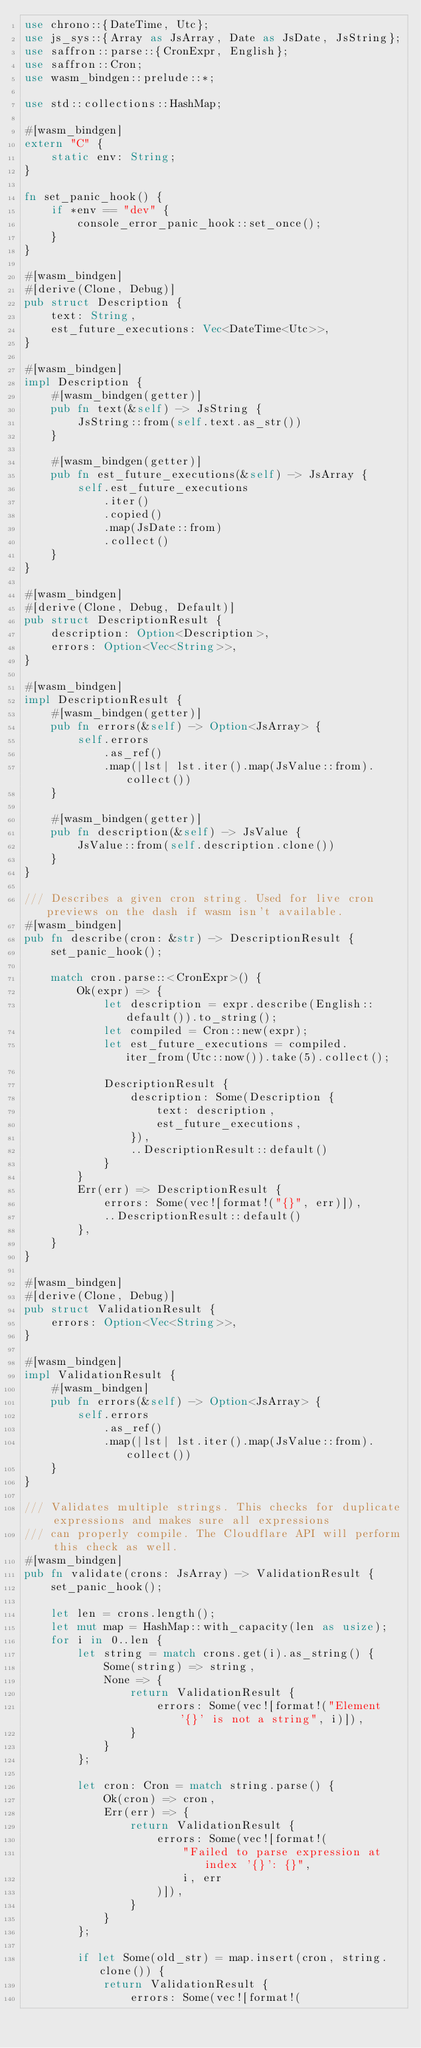Convert code to text. <code><loc_0><loc_0><loc_500><loc_500><_Rust_>use chrono::{DateTime, Utc};
use js_sys::{Array as JsArray, Date as JsDate, JsString};
use saffron::parse::{CronExpr, English};
use saffron::Cron;
use wasm_bindgen::prelude::*;

use std::collections::HashMap;

#[wasm_bindgen]
extern "C" {
    static env: String;
}

fn set_panic_hook() {
    if *env == "dev" {
        console_error_panic_hook::set_once();
    }
}

#[wasm_bindgen]
#[derive(Clone, Debug)]
pub struct Description {
    text: String,
    est_future_executions: Vec<DateTime<Utc>>,
}

#[wasm_bindgen]
impl Description {
    #[wasm_bindgen(getter)]
    pub fn text(&self) -> JsString {
        JsString::from(self.text.as_str())
    }

    #[wasm_bindgen(getter)]
    pub fn est_future_executions(&self) -> JsArray {
        self.est_future_executions
            .iter()
            .copied()
            .map(JsDate::from)
            .collect()
    }
}

#[wasm_bindgen]
#[derive(Clone, Debug, Default)]
pub struct DescriptionResult {
    description: Option<Description>,
    errors: Option<Vec<String>>,
}

#[wasm_bindgen]
impl DescriptionResult {
    #[wasm_bindgen(getter)]
    pub fn errors(&self) -> Option<JsArray> {
        self.errors
            .as_ref()
            .map(|lst| lst.iter().map(JsValue::from).collect())
    }

    #[wasm_bindgen(getter)]
    pub fn description(&self) -> JsValue {
        JsValue::from(self.description.clone())
    }
}

/// Describes a given cron string. Used for live cron previews on the dash if wasm isn't available.
#[wasm_bindgen]
pub fn describe(cron: &str) -> DescriptionResult {
    set_panic_hook();

    match cron.parse::<CronExpr>() {
        Ok(expr) => {
            let description = expr.describe(English::default()).to_string();
            let compiled = Cron::new(expr);
            let est_future_executions = compiled.iter_from(Utc::now()).take(5).collect();

            DescriptionResult {
                description: Some(Description {
                    text: description,
                    est_future_executions,
                }),
                ..DescriptionResult::default()
            }
        }
        Err(err) => DescriptionResult {
            errors: Some(vec![format!("{}", err)]),
            ..DescriptionResult::default()
        },
    }
}

#[wasm_bindgen]
#[derive(Clone, Debug)]
pub struct ValidationResult {
    errors: Option<Vec<String>>,
}

#[wasm_bindgen]
impl ValidationResult {
    #[wasm_bindgen]
    pub fn errors(&self) -> Option<JsArray> {
        self.errors
            .as_ref()
            .map(|lst| lst.iter().map(JsValue::from).collect())
    }
}

/// Validates multiple strings. This checks for duplicate expressions and makes sure all expressions
/// can properly compile. The Cloudflare API will perform this check as well.
#[wasm_bindgen]
pub fn validate(crons: JsArray) -> ValidationResult {
    set_panic_hook();

    let len = crons.length();
    let mut map = HashMap::with_capacity(len as usize);
    for i in 0..len {
        let string = match crons.get(i).as_string() {
            Some(string) => string,
            None => {
                return ValidationResult {
                    errors: Some(vec![format!("Element '{}' is not a string", i)]),
                }
            }
        };

        let cron: Cron = match string.parse() {
            Ok(cron) => cron,
            Err(err) => {
                return ValidationResult {
                    errors: Some(vec![format!(
                        "Failed to parse expression at index '{}': {}",
                        i, err
                    )]),
                }
            }
        };

        if let Some(old_str) = map.insert(cron, string.clone()) {
            return ValidationResult {
                errors: Some(vec![format!(</code> 